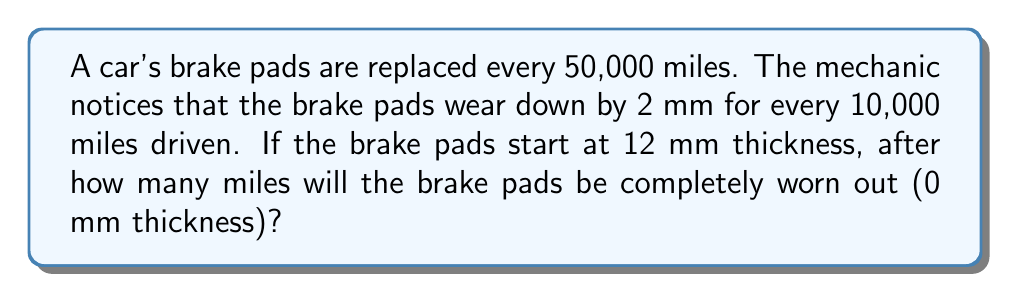Show me your answer to this math problem. Let's approach this step-by-step:

1) First, we need to determine the rate of wear:
   $\frac{2 \text{ mm}}{10,000 \text{ miles}} = 0.0002 \text{ mm/mile}$

2) Now, we know the initial thickness is 12 mm, and we want to find out how many miles it takes to wear down to 0 mm.

3) We can set up an equation:
   $12 - 0.0002x = 0$
   Where $x$ is the number of miles driven

4) Solving for $x$:
   $12 = 0.0002x$
   $x = \frac{12}{0.0002} = 60,000$

5) Therefore, the brake pads will be completely worn out after 60,000 miles.

6) We can verify this:
   $60,000 \text{ miles} \times \frac{2 \text{ mm}}{10,000 \text{ miles}} = 12 \text{ mm}$

This matches our initial thickness, confirming our calculation.
Answer: 60,000 miles 